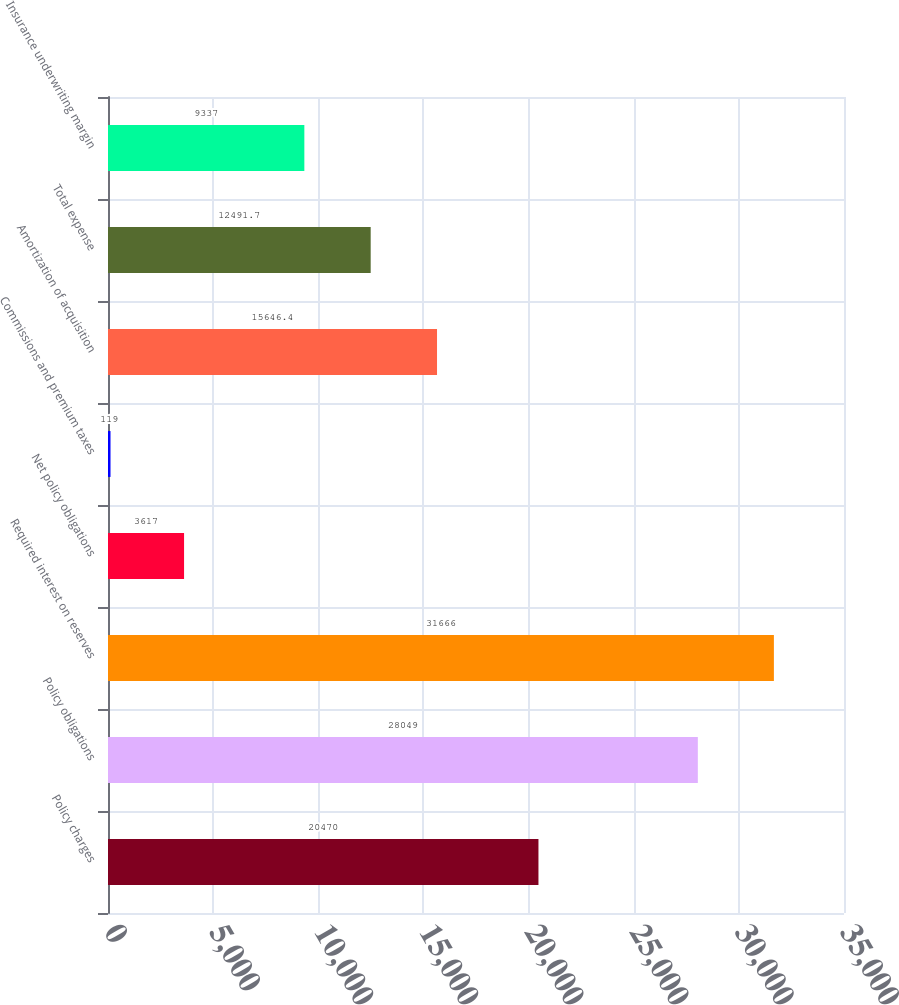Convert chart. <chart><loc_0><loc_0><loc_500><loc_500><bar_chart><fcel>Policy charges<fcel>Policy obligations<fcel>Required interest on reserves<fcel>Net policy obligations<fcel>Commissions and premium taxes<fcel>Amortization of acquisition<fcel>Total expense<fcel>Insurance underwriting margin<nl><fcel>20470<fcel>28049<fcel>31666<fcel>3617<fcel>119<fcel>15646.4<fcel>12491.7<fcel>9337<nl></chart> 